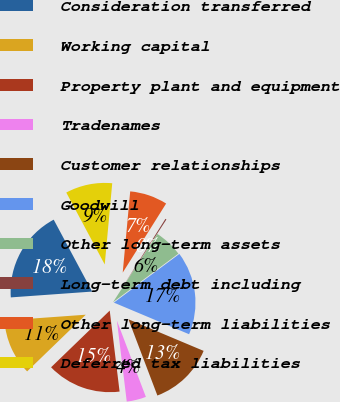Convert chart to OTSL. <chart><loc_0><loc_0><loc_500><loc_500><pie_chart><fcel>Consideration transferred<fcel>Working capital<fcel>Property plant and equipment<fcel>Tradenames<fcel>Customer relationships<fcel>Goodwill<fcel>Other long-term assets<fcel>Long-term debt including<fcel>Other long-term liabilities<fcel>Deferred tax liabilities<nl><fcel>18.32%<fcel>11.09%<fcel>14.7%<fcel>3.85%<fcel>12.89%<fcel>16.51%<fcel>5.66%<fcel>0.23%<fcel>7.47%<fcel>9.28%<nl></chart> 